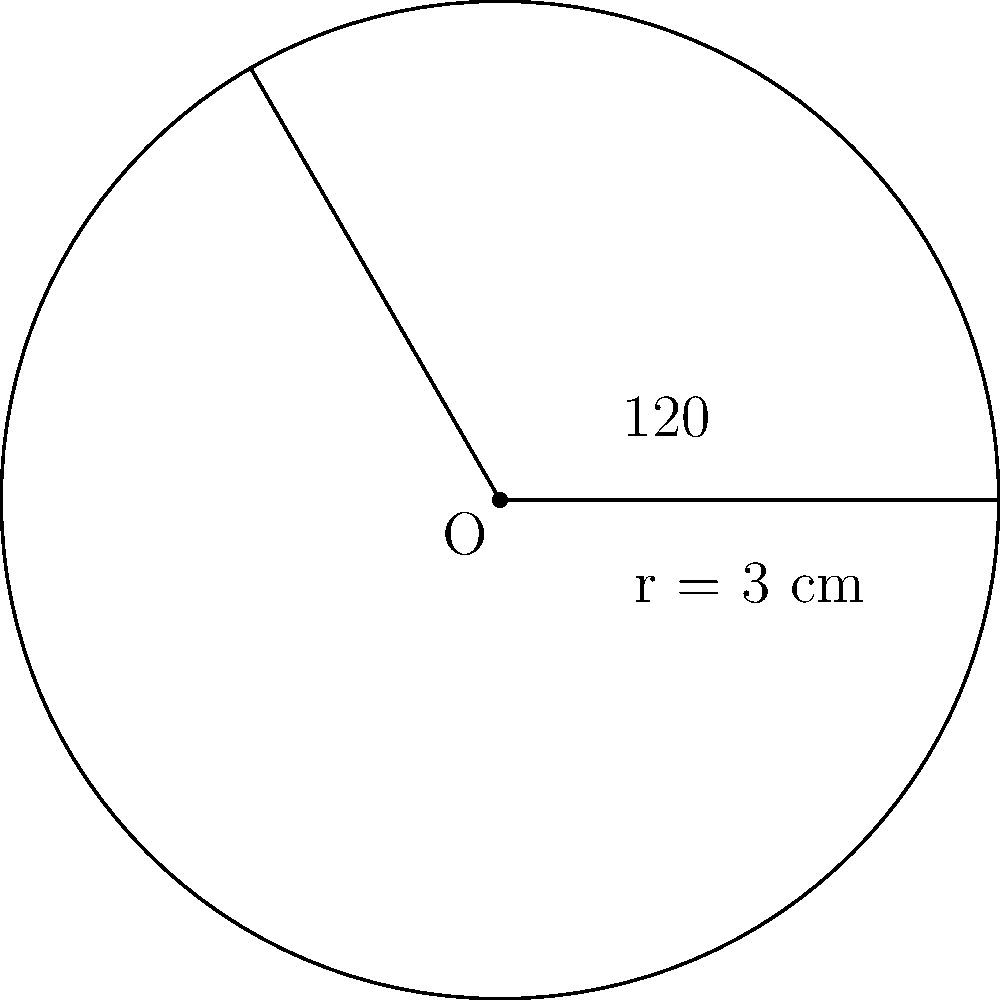In a genomic database visualization, a circular sector represents a specific gene cluster. The sector has a central angle of $120°$ and a radius of 3 cm. Calculate the area of this sector, which corresponds to the relative size of the gene cluster in the database. Round your answer to two decimal places. To find the area of a circular sector, we can follow these steps:

1) The formula for the area of a circular sector is:

   $$A = \frac{1}{2} r^2 \theta$$

   Where $A$ is the area, $r$ is the radius, and $\theta$ is the central angle in radians.

2) We're given the radius $r = 3$ cm and the central angle of $120°$. However, we need to convert the angle to radians:

   $$\theta = 120° \times \frac{\pi}{180°} = \frac{2\pi}{3} \approx 2.0944 \text{ radians}$$

3) Now we can substitute these values into our formula:

   $$A = \frac{1}{2} \times 3^2 \times \frac{2\pi}{3}$$

4) Simplify:
   
   $$A = \frac{9\pi}{3} = 3\pi \approx 9.4248 \text{ cm}^2$$

5) Rounding to two decimal places:

   $$A \approx 9.42 \text{ cm}^2$$
Answer: $9.42 \text{ cm}^2$ 